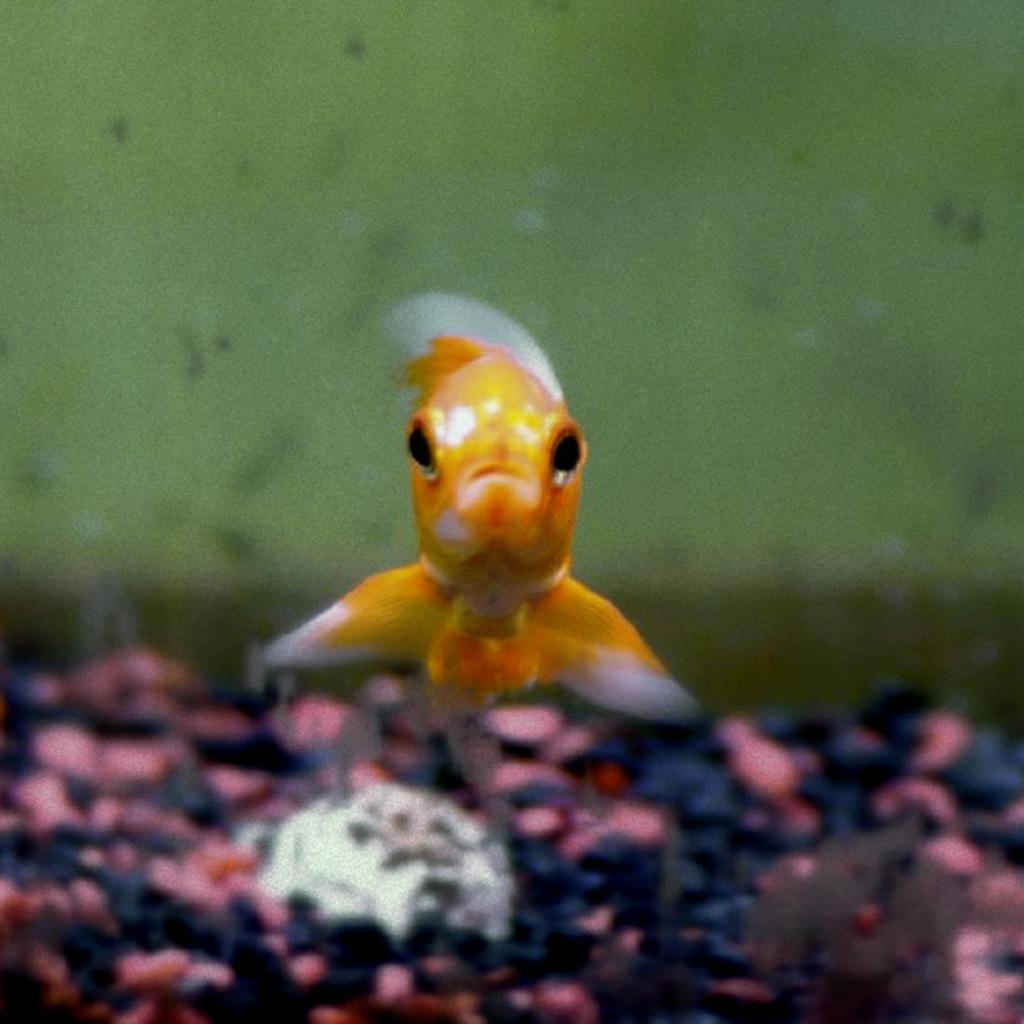What type of animal is in the image? There is a golden fish in the image. Can you tell me how many cobwebs are present in the image? There is no mention of cobwebs in the image, so it is not possible to determine their presence or quantity. 